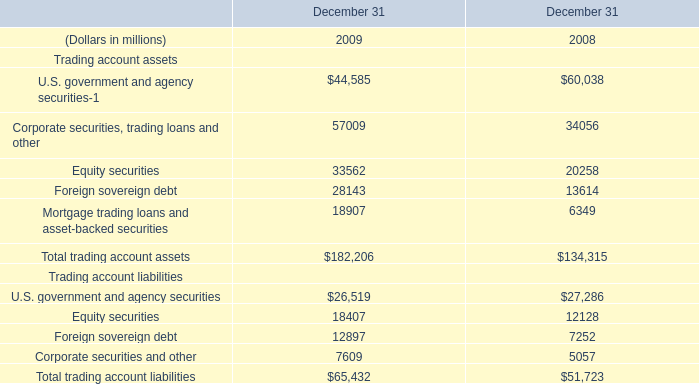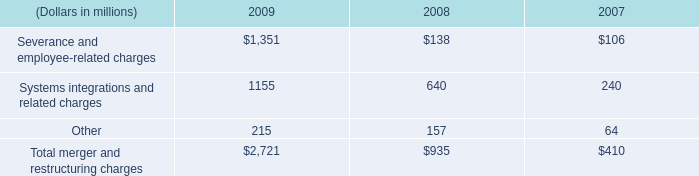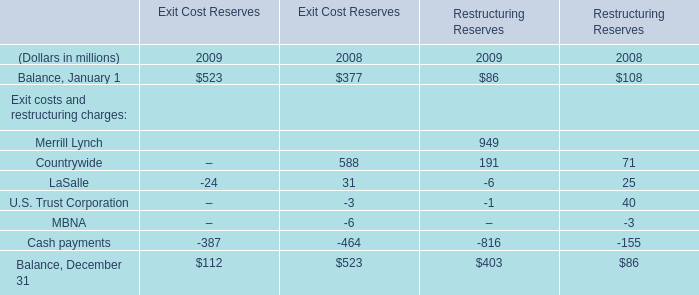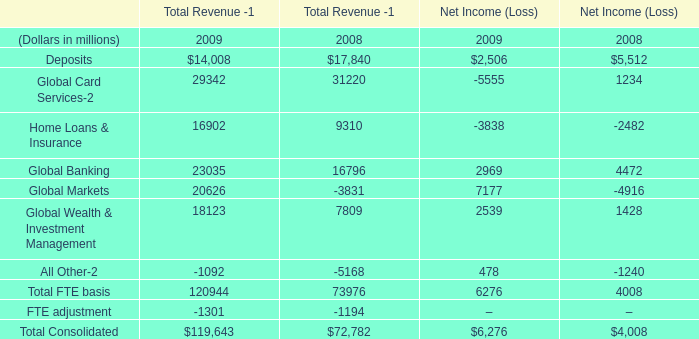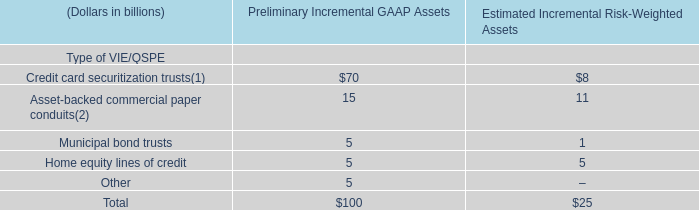What's the current increasing rate of total merger and restructuring charges? 
Computations: ((2721 - 935) / 935)
Answer: 1.91016. 